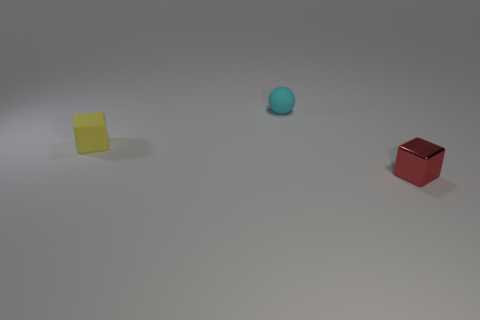Is there anything else that is the same material as the red block?
Give a very brief answer. No. The red thing is what size?
Provide a succinct answer. Small. There is a block that is to the left of the object that is in front of the tiny yellow matte object; are there any blocks that are behind it?
Offer a very short reply. No. What is the shape of the yellow rubber object that is the same size as the shiny thing?
Provide a short and direct response. Cube. How many large objects are either cyan rubber objects or brown cylinders?
Keep it short and to the point. 0. What is the color of the tiny sphere that is the same material as the tiny yellow object?
Provide a short and direct response. Cyan. There is a rubber thing behind the yellow rubber thing; is it the same shape as the rubber object in front of the small sphere?
Your answer should be very brief. No. How many rubber objects are either tiny spheres or big cyan objects?
Ensure brevity in your answer.  1. Is there anything else that is the same shape as the yellow thing?
Your answer should be very brief. Yes. There is a block to the left of the red metallic block; what is its material?
Your response must be concise. Rubber. 